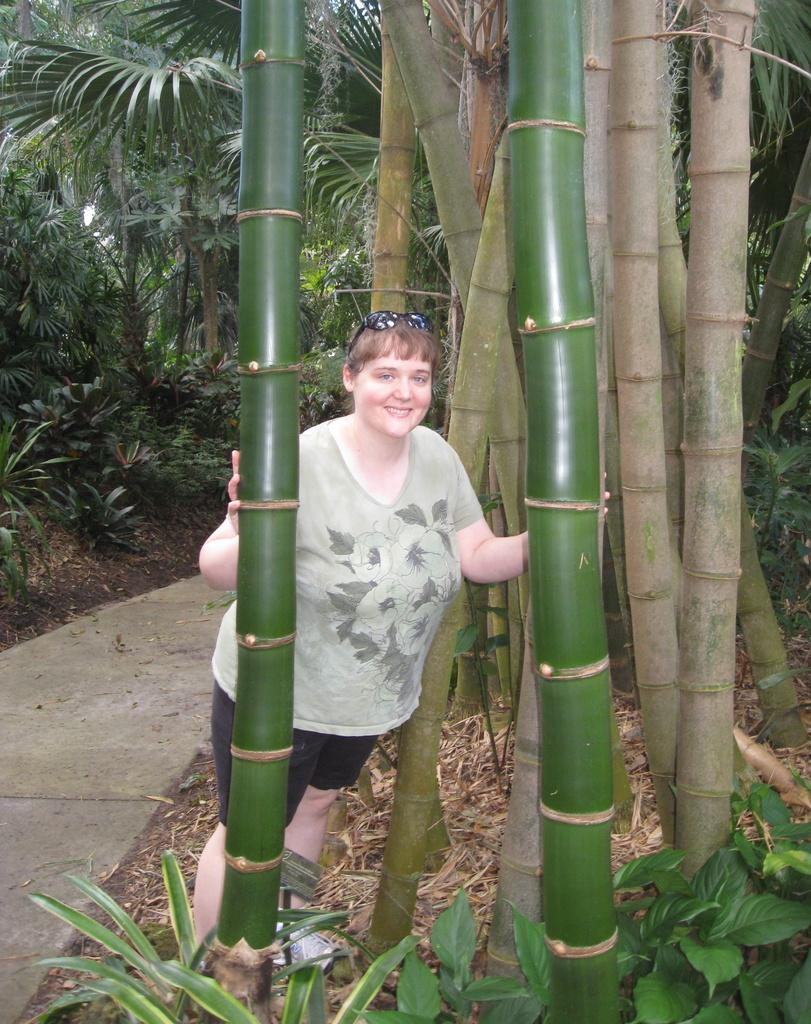What is the main subject in the image? There is a woman standing in the image. What can be seen in the image besides the woman? There are plants and trees visible in the image. Can you describe the trees in the image? There are trees in the image, and there are also trees in the background of the image. How much honey is the woman holding in the image? There is no honey present in the image. What direction is the woman walking in the image? The woman is not walking in the image; she is standing still. 